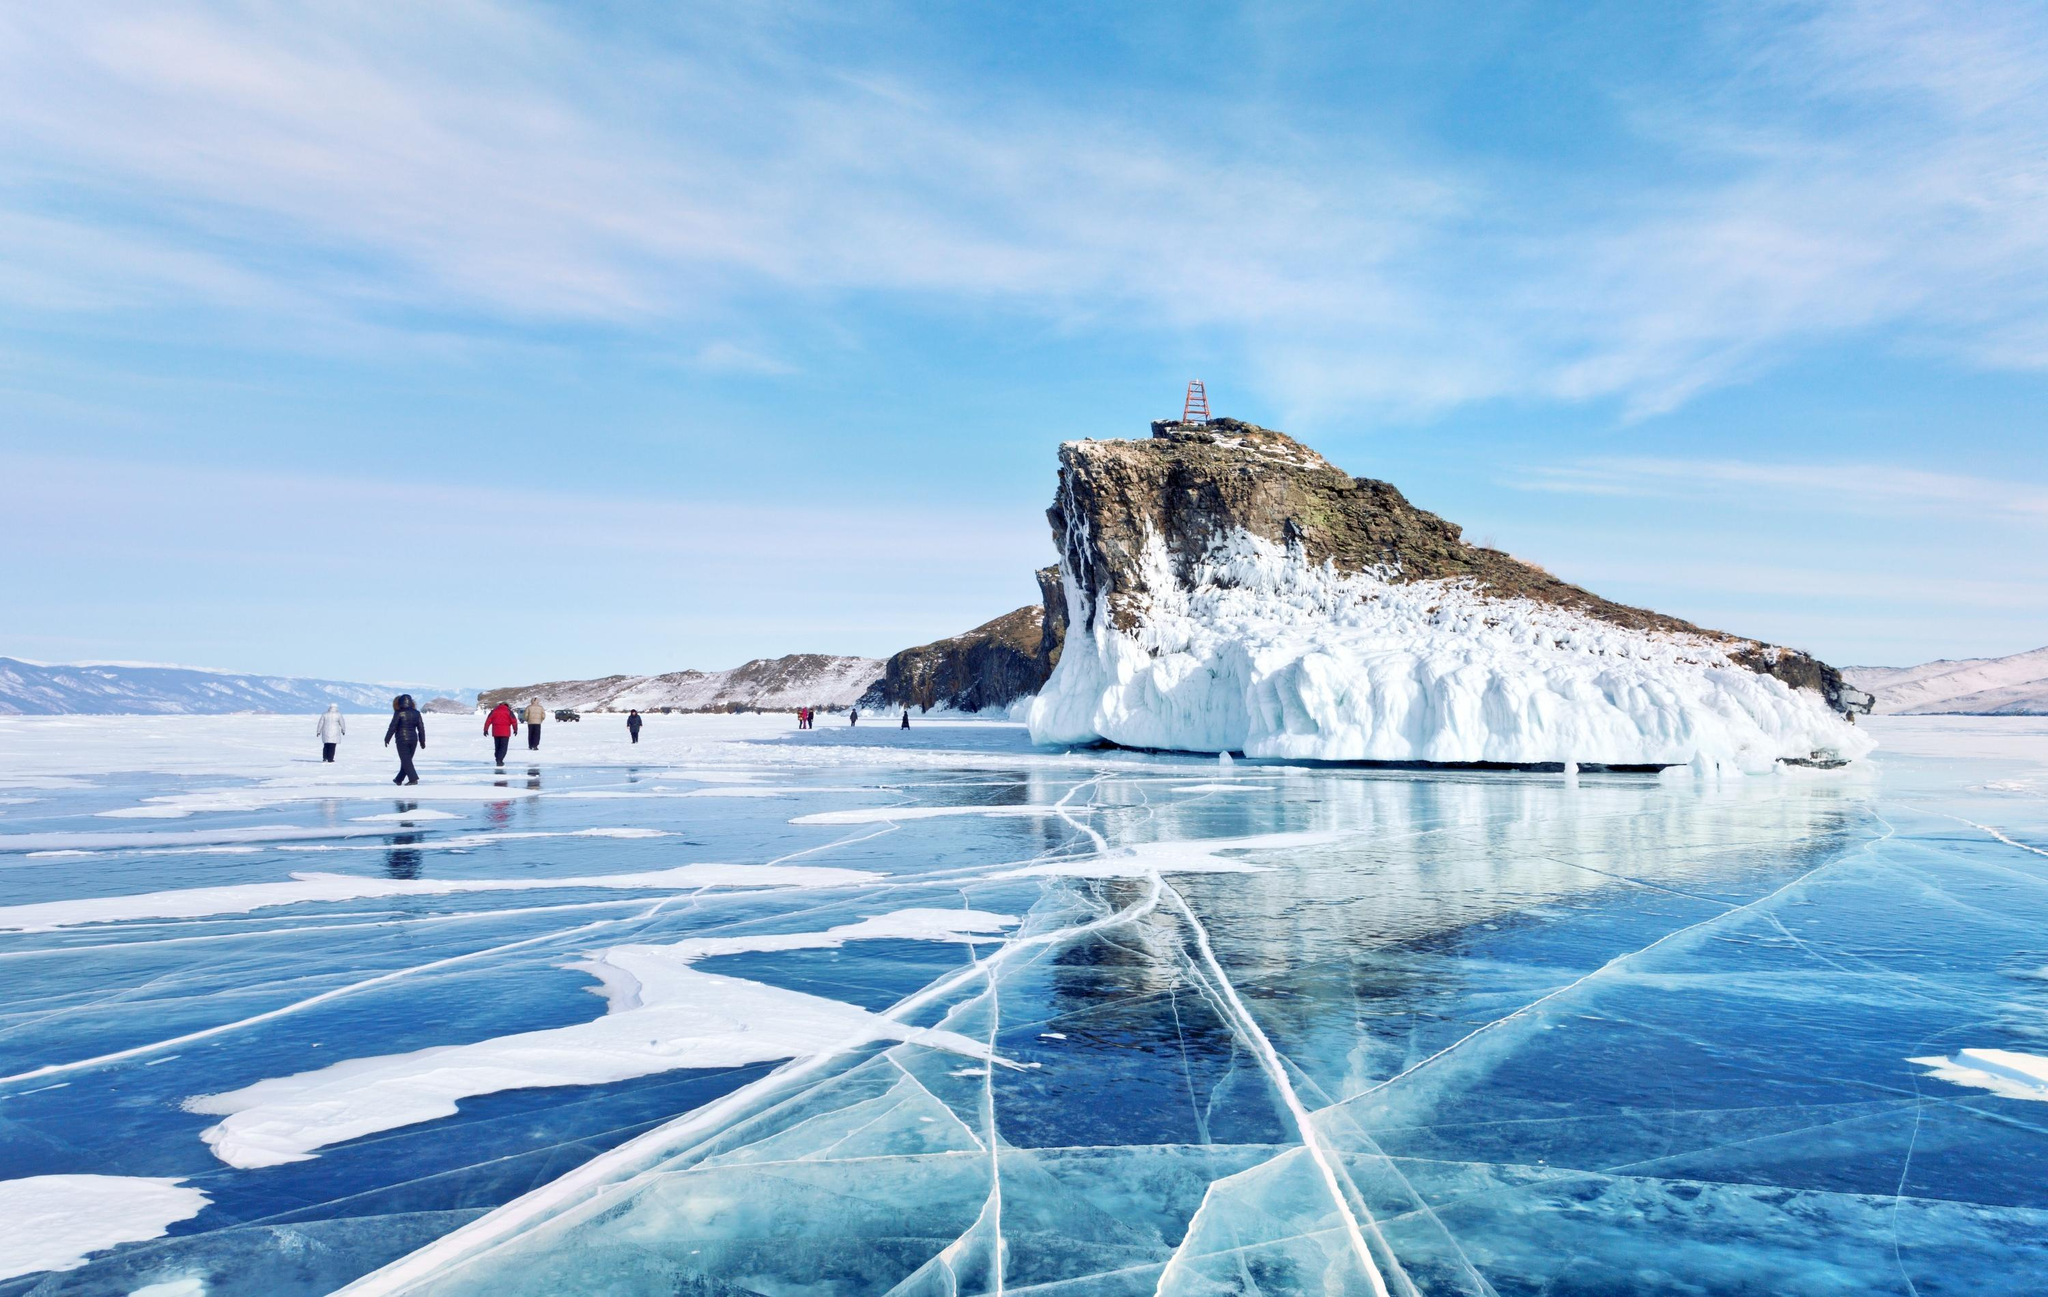What do you think is going on in this snapshot?
 The image captures the breathtaking beauty of Lake Baikal, the world's deepest and oldest lake. The perspective is from the frozen surface of the lake itself, giving a sense of the vastness of the icy expanse. The ice, with its blue tint and visible cracks, adds a unique texture to the scene.

A group of people can be seen walking on the ice, their figures small against the grandeur of the landscape. They are heading towards a rocky island, which stands out against the clear blue sky. The island is covered in snow and ice, reflecting the harsh winter conditions. Atop the island, a lighthouse stands as a solitary sentinel, guiding the way for those navigating these icy waters.

The image is a testament to the stark beauty of Lake Baikal and the resilience of those who venture out onto its frozen surface. It's a snapshot of a moment in time, capturing the interaction between humans and nature in one of the world's most unique landscapes. 